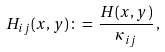<formula> <loc_0><loc_0><loc_500><loc_500>H _ { i j } ( x , y ) \, \colon = \, \frac { H ( x , y ) } { \kappa _ { i j } } \, ,</formula> 